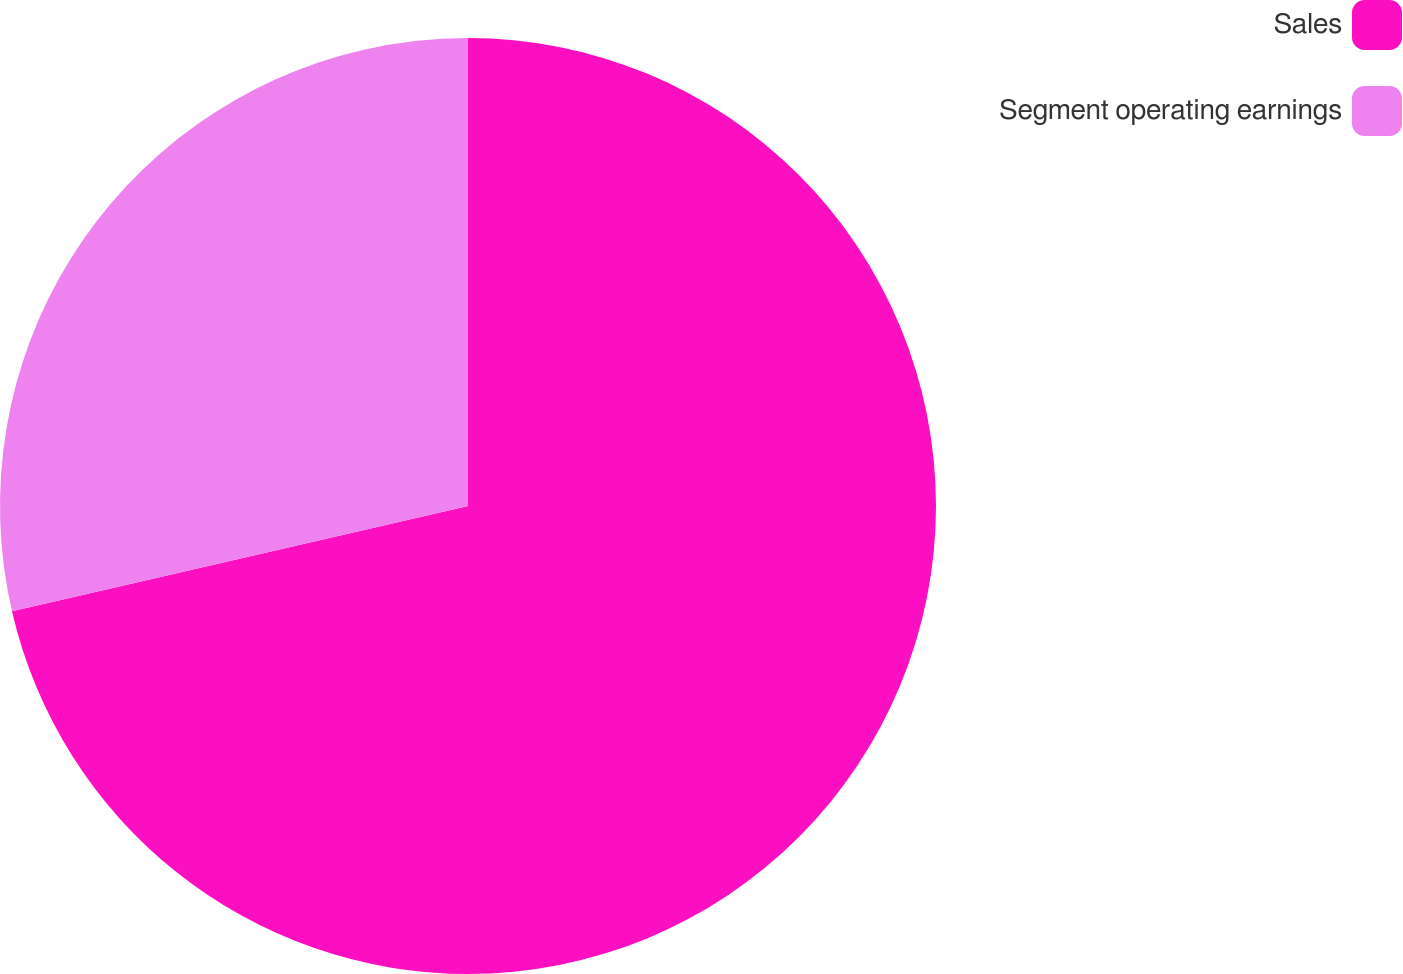<chart> <loc_0><loc_0><loc_500><loc_500><pie_chart><fcel>Sales<fcel>Segment operating earnings<nl><fcel>71.39%<fcel>28.61%<nl></chart> 